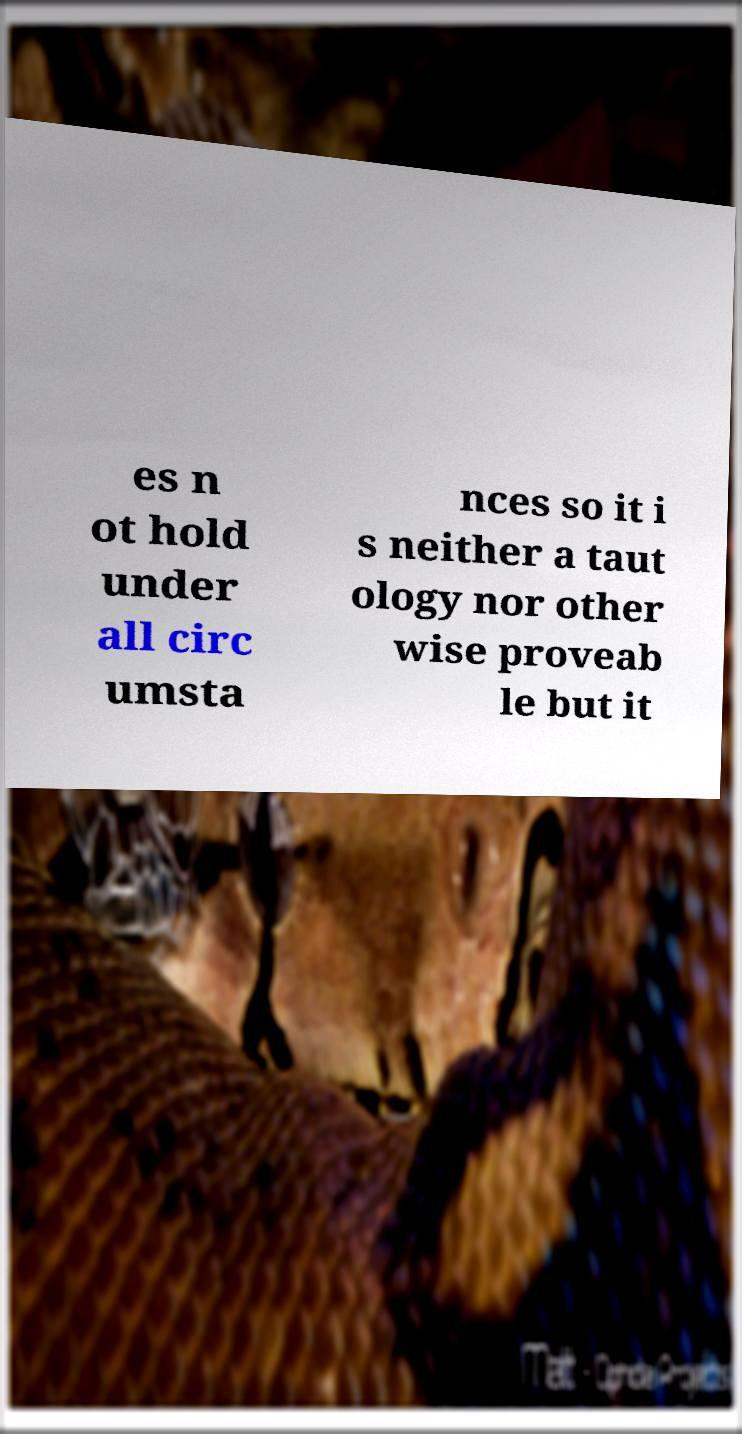Please read and relay the text visible in this image. What does it say? es n ot hold under all circ umsta nces so it i s neither a taut ology nor other wise proveab le but it 